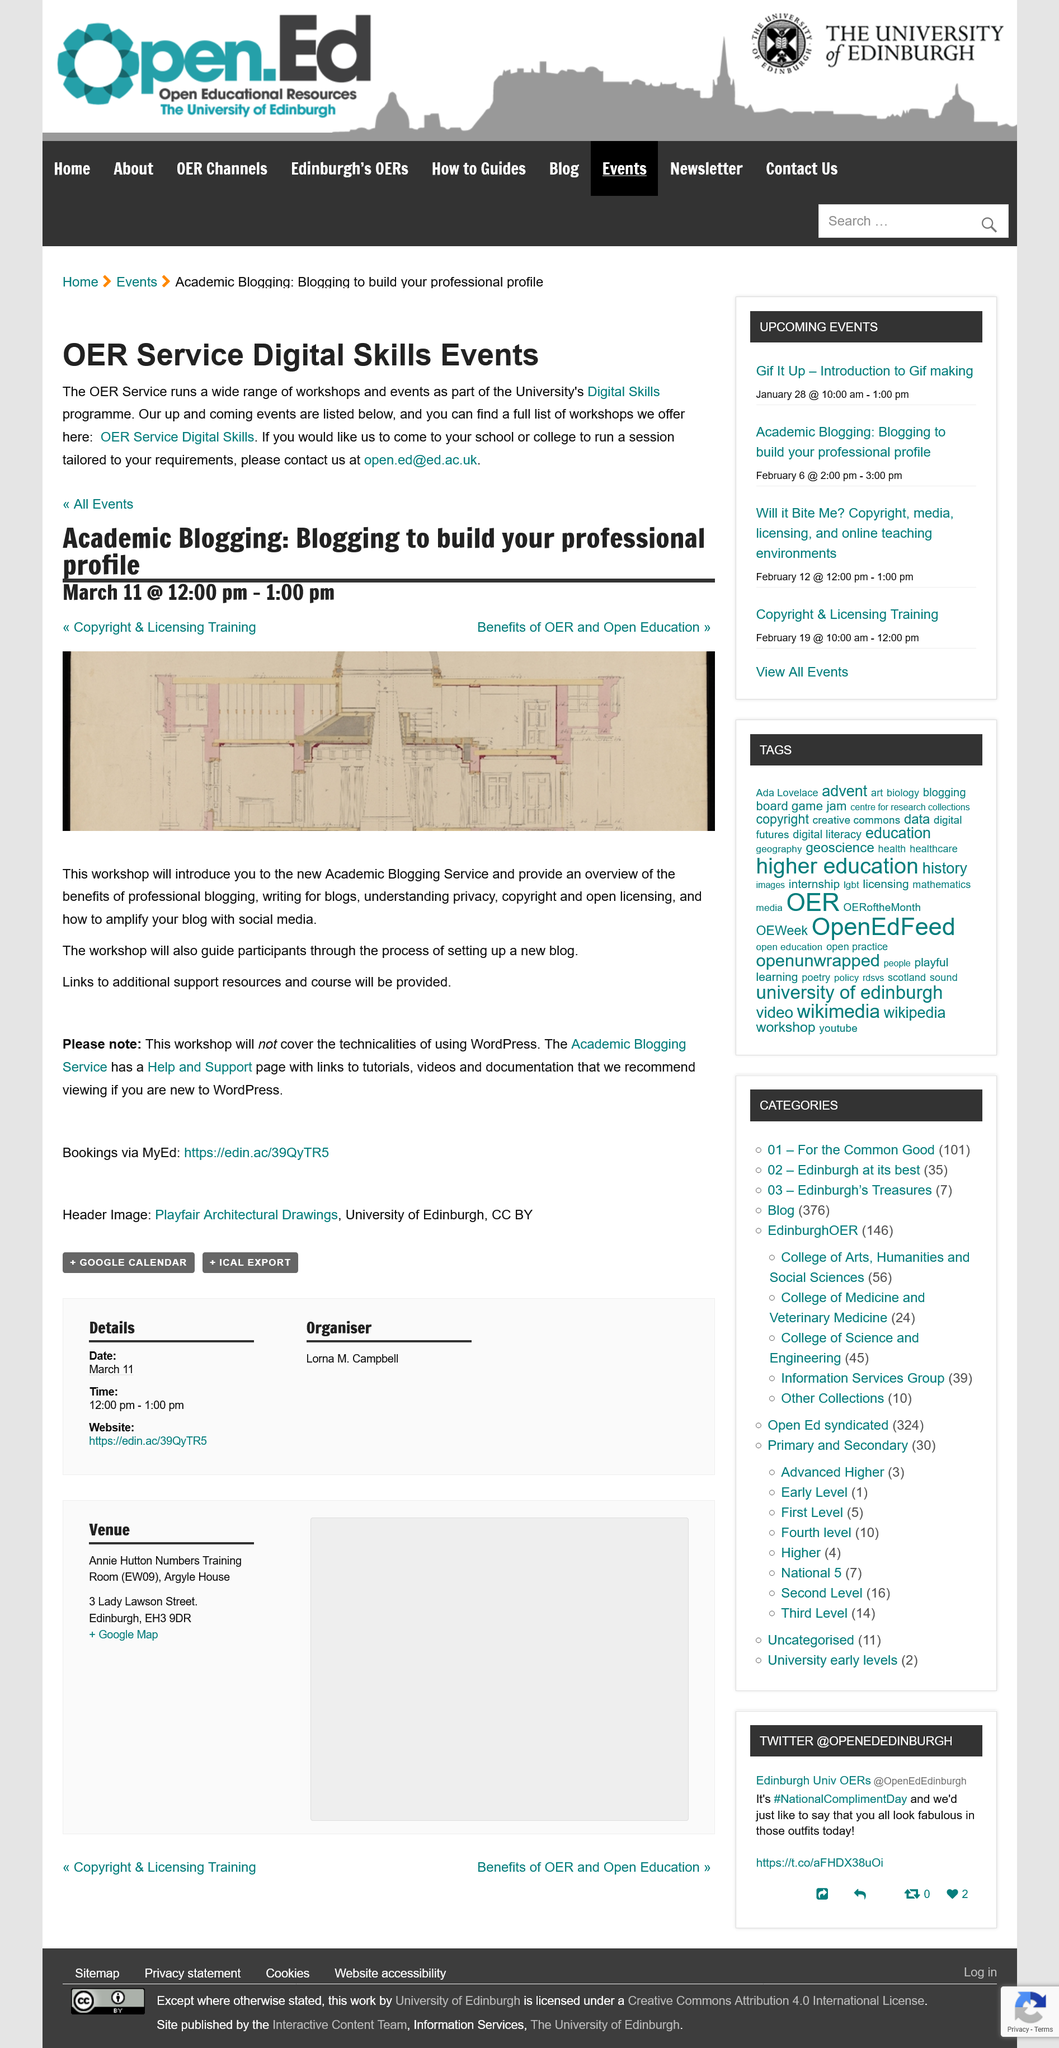Outline some significant characteristics in this image. This workshop effectively guides participants through the process of setting up a new blog and amplifying it with social media. This workshop does not cover the technicalities of using WordPress. Yes, the Academic Blogging Service has a Help and Support page. 